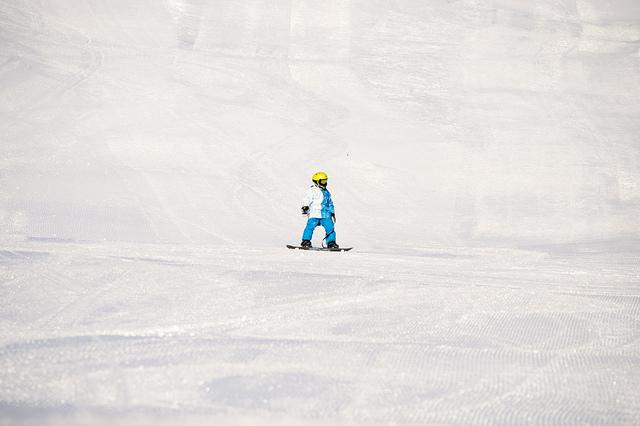Is this an adult?
Short answer required. No. What color helmet is this person wearing?
Give a very brief answer. Yellow. Is this skier going fast?
Short answer required. No. What are these people doing?
Write a very short answer. Snowboarding. How many people are shown?
Short answer required. 1. What is on the man's feet?
Answer briefly. Snowboard. How many people are wearing a hat?
Write a very short answer. 1. What is in the picture?
Be succinct. Snowboarder. What color is the left person's coat?
Give a very brief answer. Blue and white. 